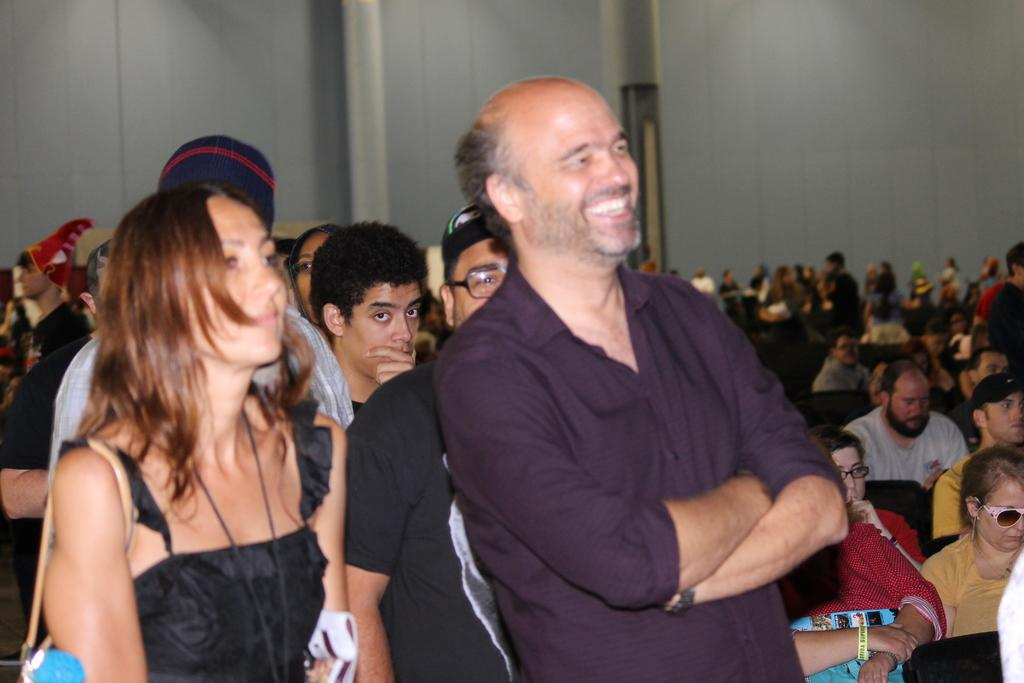How many people are in the image? The number of people in the image is not specified, but there are people present. What are some of the people in the image doing? Some people in the image are sitting. What type of structure can be seen in the image? Walls are visible in the image, which suggests a room or building. What type of grass is growing on the sofa in the image? There is no sofa or grass present in the image. 